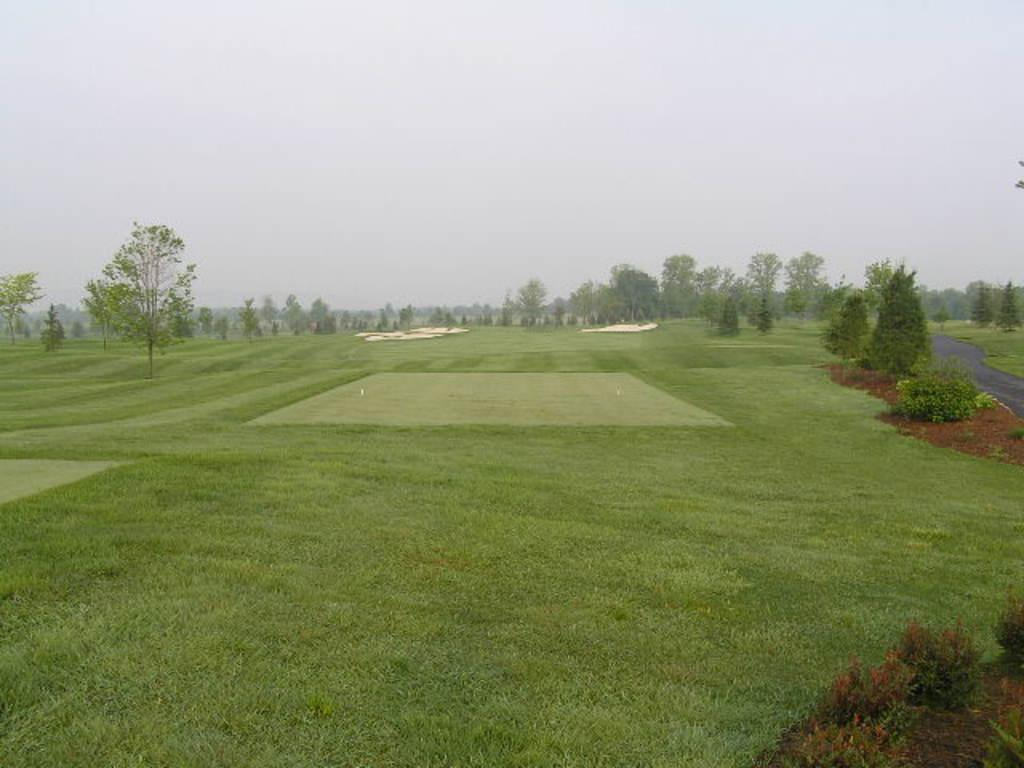What type of vegetation is at the bottom of the image? There is grass at the bottom of the image. What can be seen in the middle of the image? There are trees and plants in the middle of the image. What type of man-made structure is present in the middle of the image? There is a road in the middle of the image. What is visible at the top of the image? The sky is visible at the top of the image. How many snakes are slithering across the road in the image? There are no snakes present in the image. What direction is the point in the image pointing towards? There is no point present in the image. 